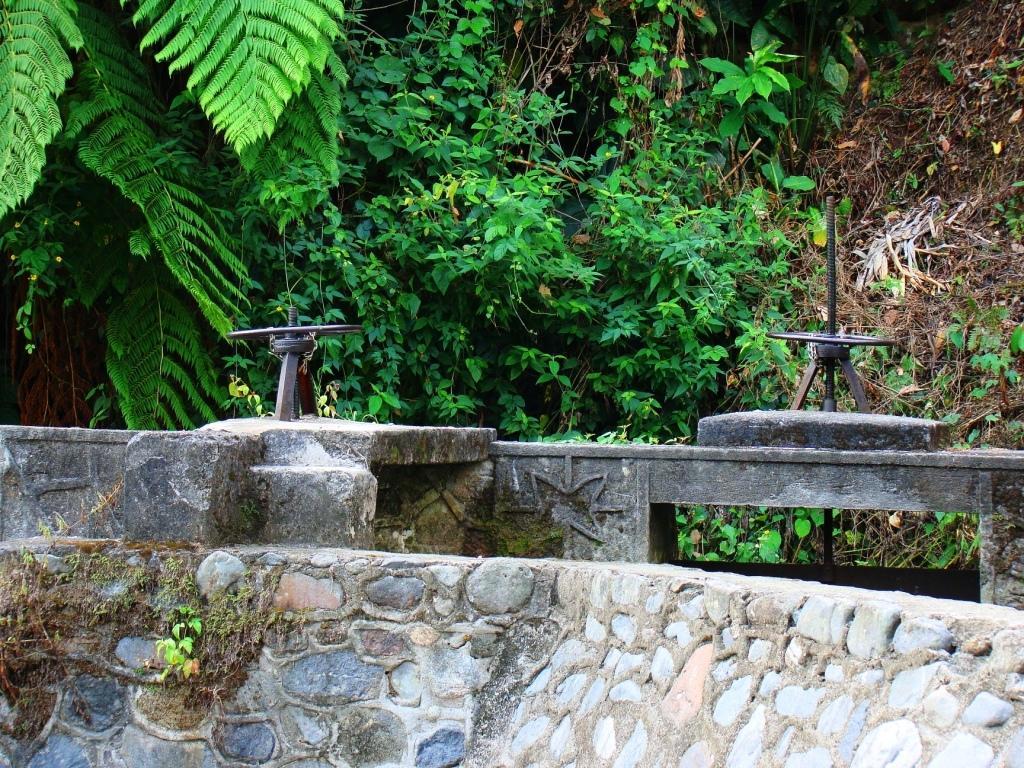In one or two sentences, can you explain what this image depicts? Here in the middle we can see rain water sprinklers present on the wall over there and behind them we can see plants and trees present all over there. 